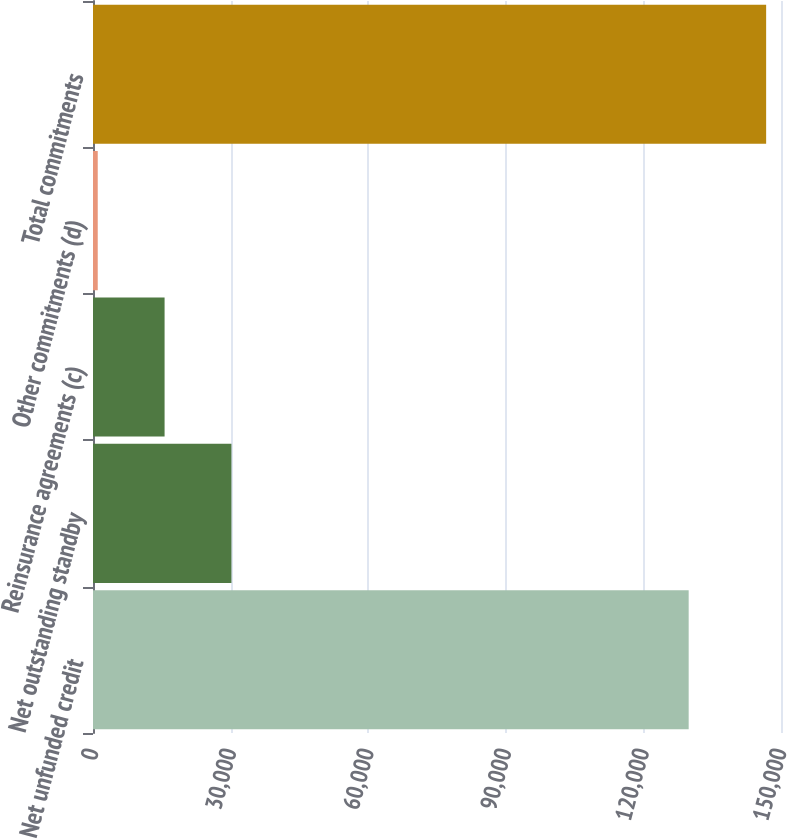Convert chart to OTSL. <chart><loc_0><loc_0><loc_500><loc_500><bar_chart><fcel>Net unfunded credit<fcel>Net outstanding standby<fcel>Reinsurance agreements (c)<fcel>Other commitments (d)<fcel>Total commitments<nl><fcel>129870<fcel>30179.2<fcel>15606.6<fcel>1034<fcel>146760<nl></chart> 